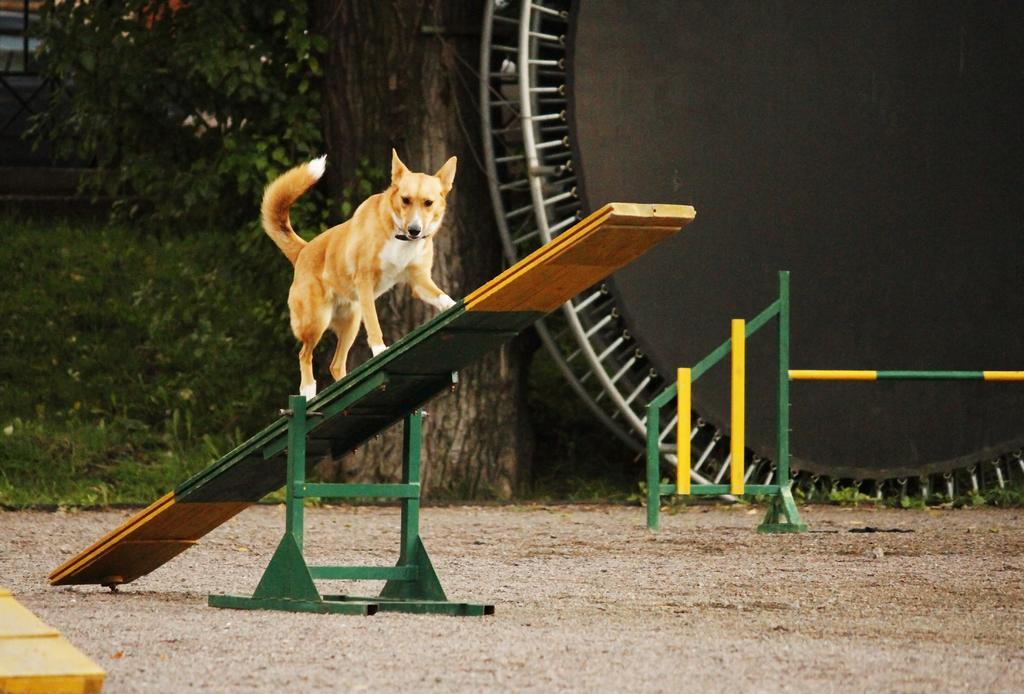Can you describe this image briefly? In the center of the image we can see a slide. On the slide, we can see a dog. At the bottom left side of the image, we can see an object. In the background, we can see the grass, one tree and a few other objects. 